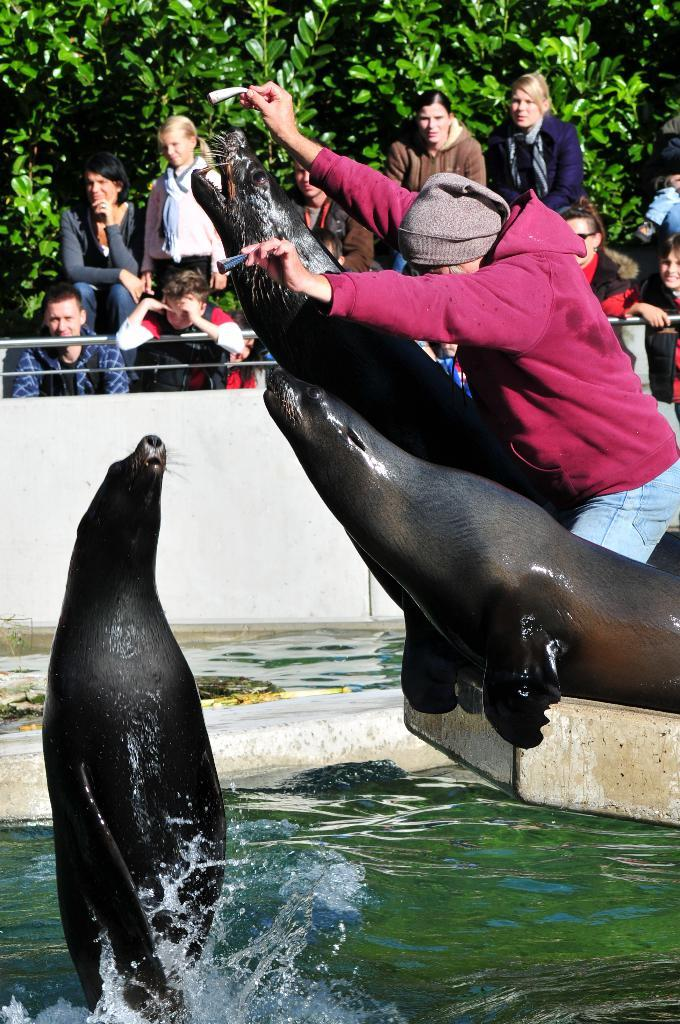How many people are in the image? There are people in the image, but the exact number is not specified. What is one person doing in the image? One person is holding objects in the image. What type of animals are in the image? There are sea lions in the image. What is the primary setting of the image? There is water visible in the image, suggesting a water-based environment. What is the background of the image composed of? The background of the image includes a wall and leaves. What type of light is being used to illuminate the fork in the image? There is no fork present in the image, so it is not possible to determine what type of light might be used to illuminate it. How many boys are visible in the image? The facts do not specify the gender of the people in the image, so it is not possible to determine the number of boys. 